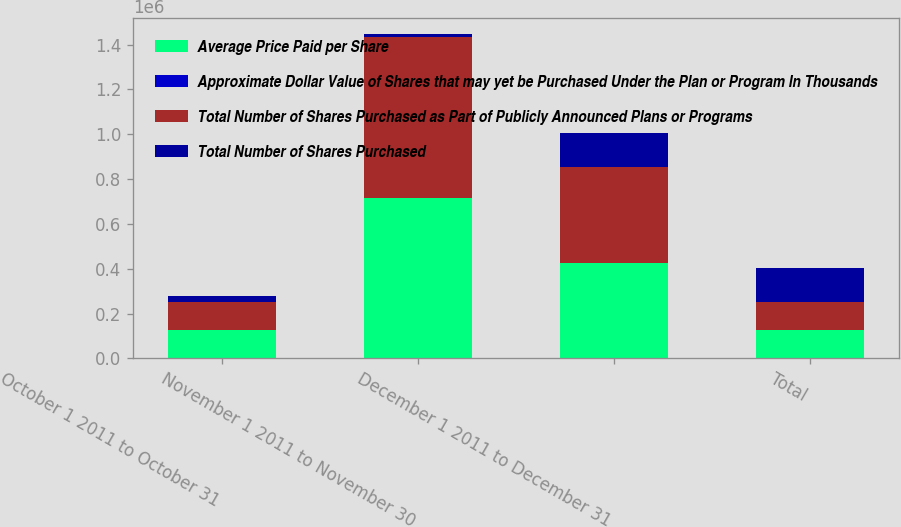<chart> <loc_0><loc_0><loc_500><loc_500><stacked_bar_chart><ecel><fcel>October 1 2011 to October 31<fcel>November 1 2011 to November 30<fcel>December 1 2011 to December 31<fcel>Total<nl><fcel>Average Price Paid per Share<fcel>125621<fcel>717639<fcel>427355<fcel>125621<nl><fcel>Approximate Dollar Value of Shares that may yet be Purchased Under the Plan or Program In Thousands<fcel>25.69<fcel>24.98<fcel>24.45<fcel>24.87<nl><fcel>Total Number of Shares Purchased as Part of Publicly Announced Plans or Programs<fcel>125621<fcel>717639<fcel>427355<fcel>125621<nl><fcel>Total Number of Shares Purchased<fcel>29421<fcel>11494<fcel>151046<fcel>151046<nl></chart> 